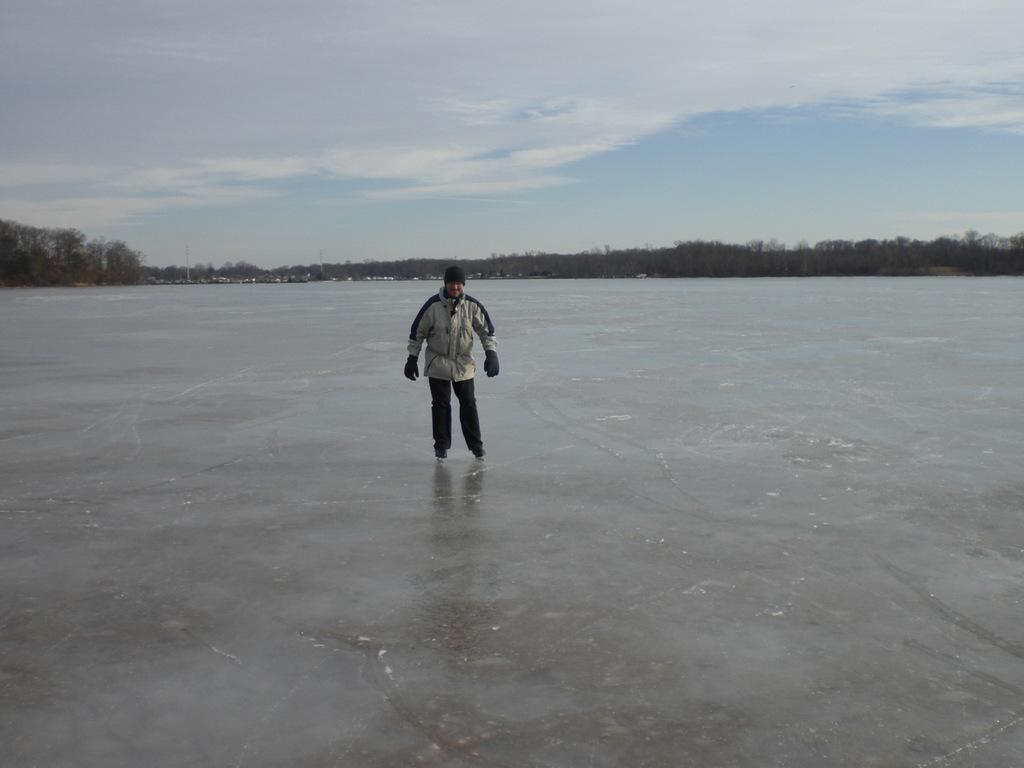Who is the main subject in the image? There is a man in the middle of the image. What is the man wearing? The man is wearing a coat, trousers, and a cap. What can be seen on the left side of the image? There are green trees on the left side of the image. How would you describe the sky in the image? The sky is cloudy at the top of the image. Can you tell me what action the sheep is performing in the image? There are no sheep present in the image. What does the man show to the camera in the image? The image does not depict the man performing any specific action or showing anything to the camera. 